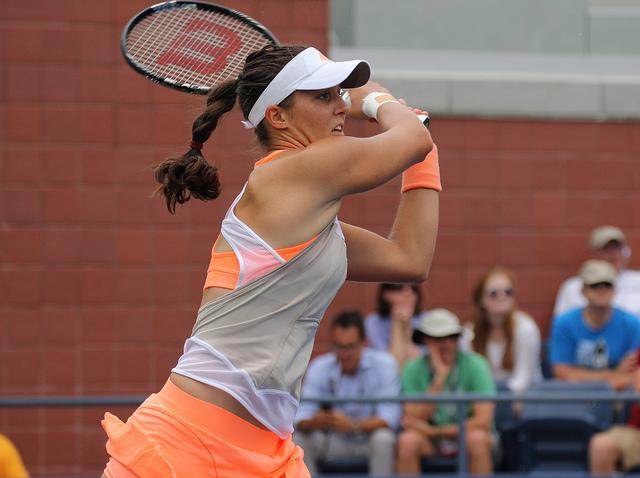What is in the picture?
Concise answer only. Tennis player. What brand is the tennis racquet?
Give a very brief answer. Wilson. Is this person wearing a belt?
Be succinct. No. What color is her sports bra?
Concise answer only. Orange. Are most of the people in the stands wearing sunglasses?
Answer briefly. Yes. 